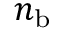Convert formula to latex. <formula><loc_0><loc_0><loc_500><loc_500>n _ { b }</formula> 